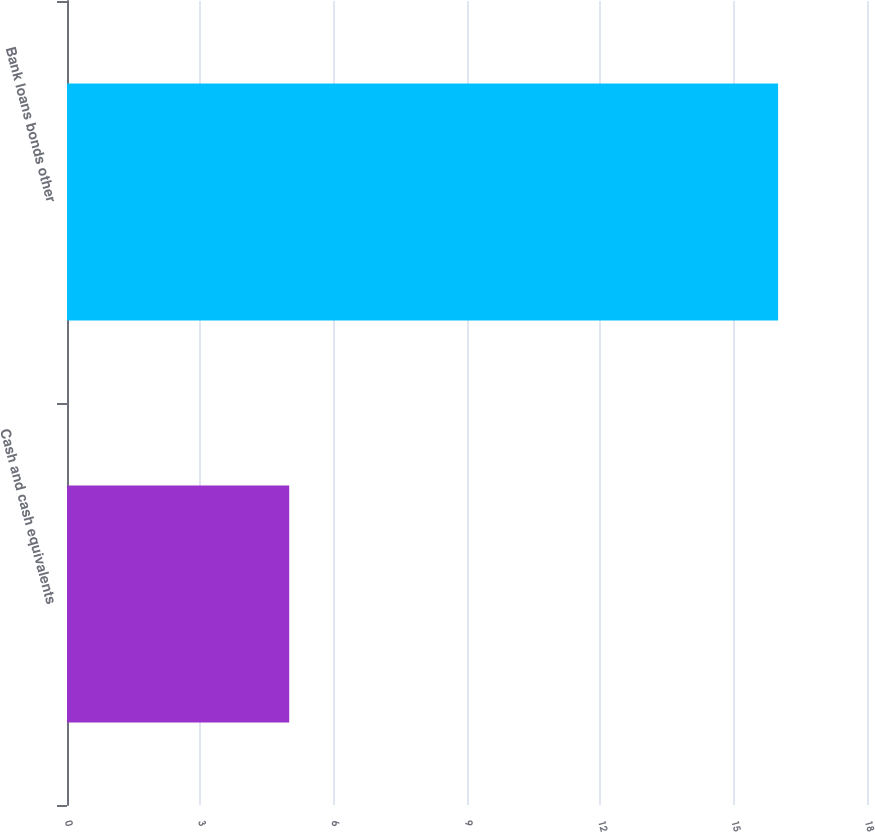<chart> <loc_0><loc_0><loc_500><loc_500><bar_chart><fcel>Cash and cash equivalents<fcel>Bank loans bonds other<nl><fcel>5<fcel>16<nl></chart> 